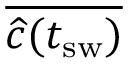<formula> <loc_0><loc_0><loc_500><loc_500>\overline { { \widehat { c } ( t _ { s w } ) } }</formula> 